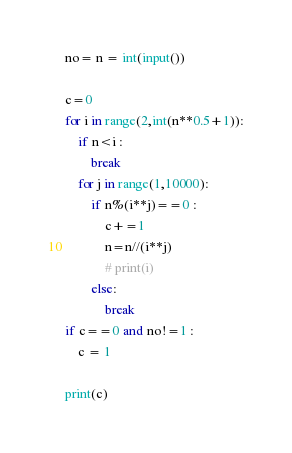<code> <loc_0><loc_0><loc_500><loc_500><_Python_>no= n = int(input())

c=0
for i in range(2,int(n**0.5+1)):
    if n<i :
        break
    for j in range(1,10000): 
        if n%(i**j)==0 :
            c+=1
            n=n//(i**j)
            # print(i)
        else:
            break
if c==0 and no!=1 :
    c = 1

print(c)


</code> 